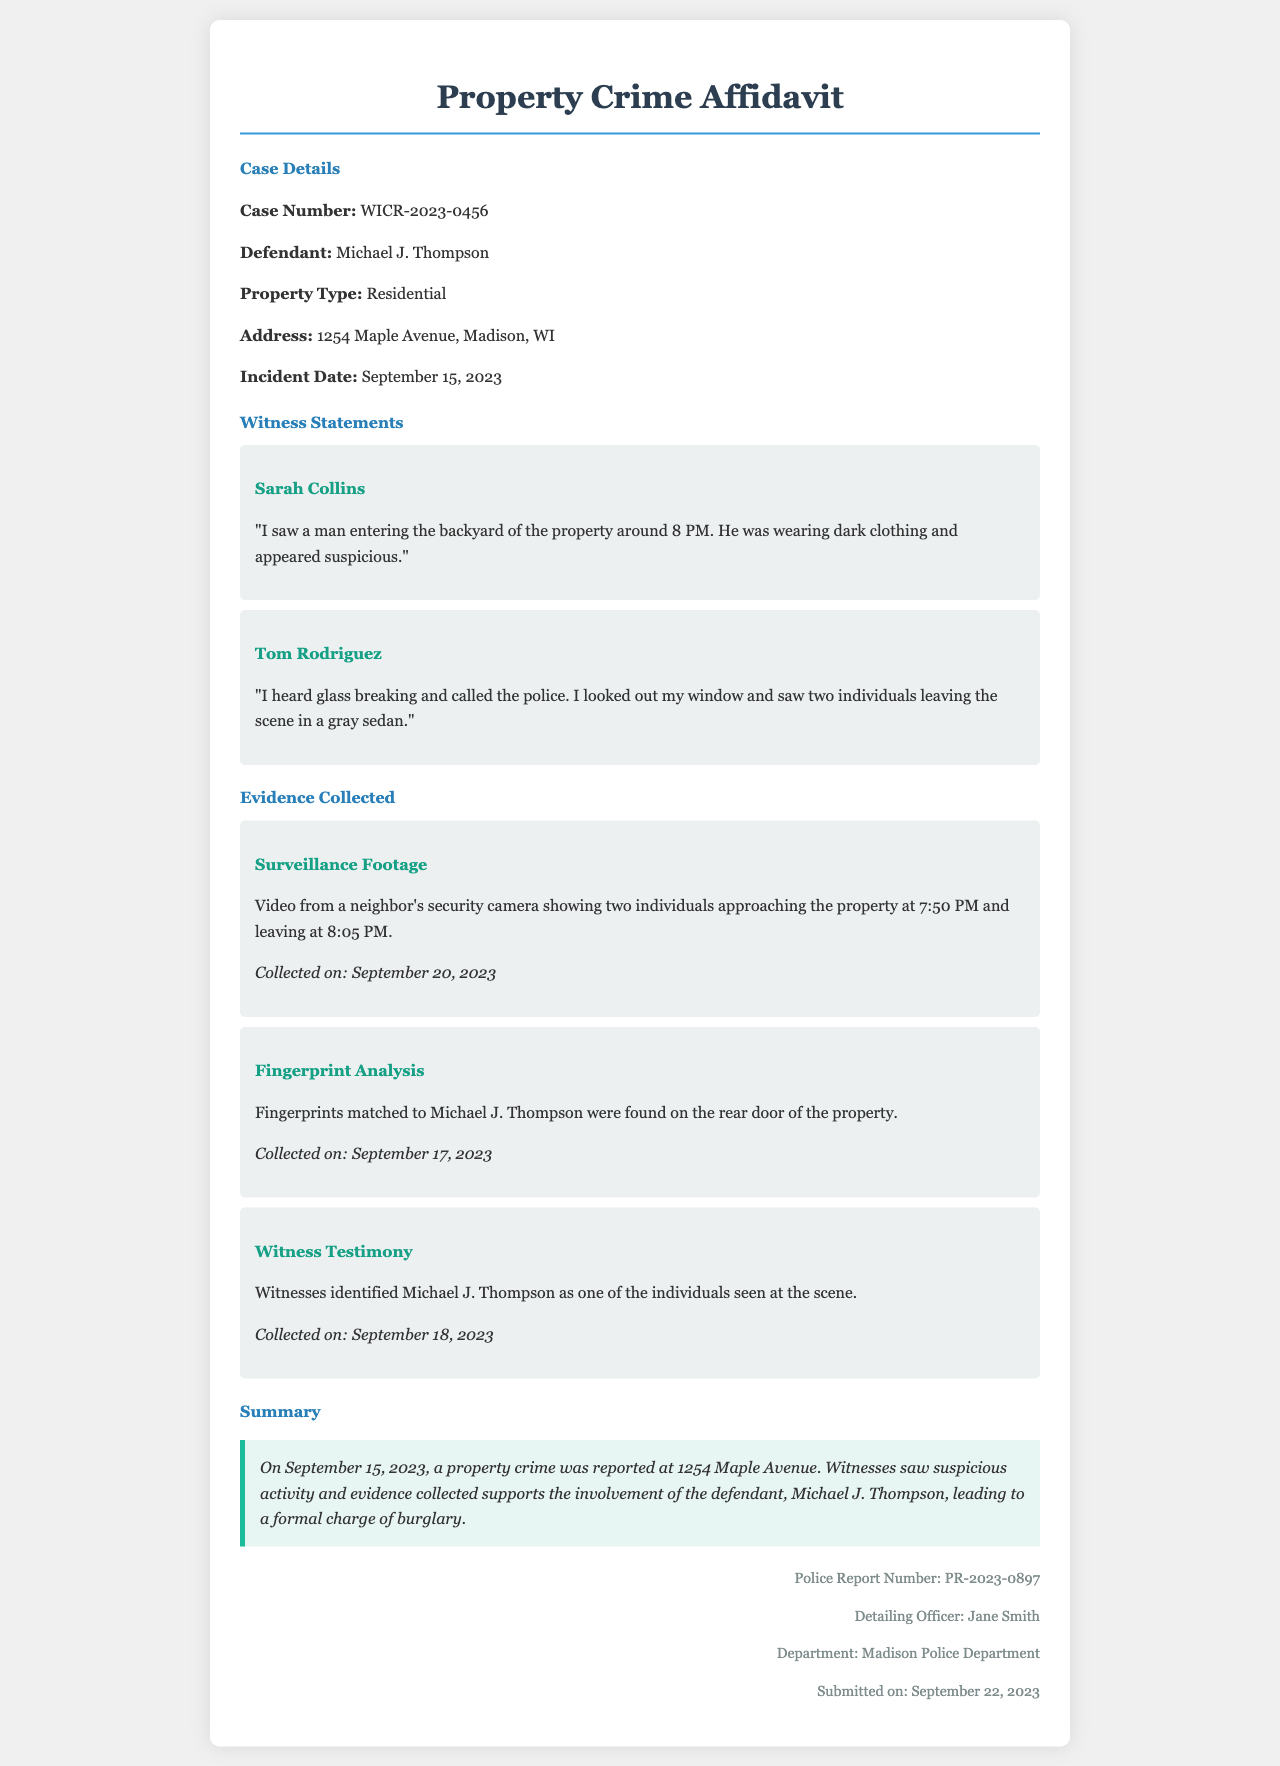What is the case number? The case number is provided in the document under Case Details.
Answer: WICR-2023-0456 Who is the defendant? The document lists the defendant's name in the Case Details section.
Answer: Michael J. Thompson What type of property was involved? The type of property is specified in the Case Details section.
Answer: Residential When did the incident occur? The date of the incident is provided in the Case Details.
Answer: September 15, 2023 What did Sarah Collins observe? The witness statement from Sarah Collins details her observation of the defendant.
Answer: A man entering the backyard What evidence was collected on September 20, 2023? The document describes the date of collection for different types of evidence.
Answer: Surveillance Footage How did the fingerprint analysis link the defendant? The document explains how the evidence matched the defendant.
Answer: Fingerprints matched to Michael J. Thompson What summary is provided regarding the incident? The summary at the end of the document provides an overview of the crime and charges.
Answer: Suspicious activity and involvement of the defendant What is the police report number? The police report number is included in the footer section of the document.
Answer: PR-2023-0897 